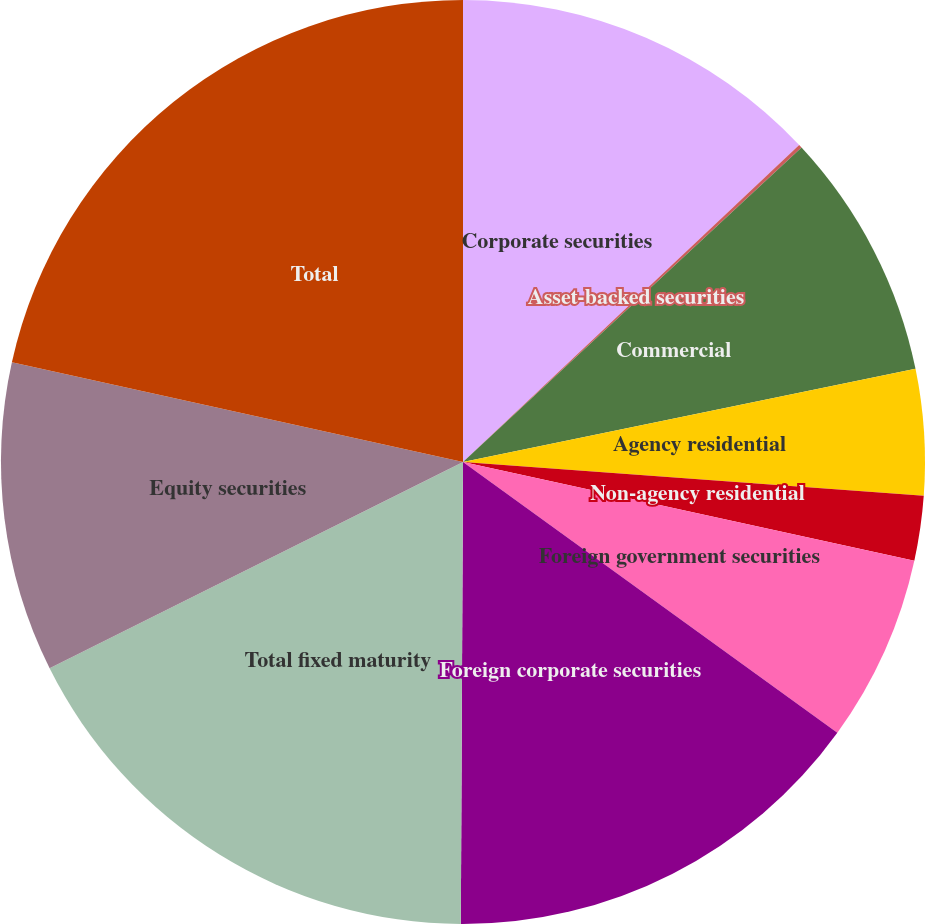Convert chart. <chart><loc_0><loc_0><loc_500><loc_500><pie_chart><fcel>Corporate securities<fcel>Asset-backed securities<fcel>Commercial<fcel>Agency residential<fcel>Non-agency residential<fcel>Foreign government securities<fcel>Foreign corporate securities<fcel>Total fixed maturity<fcel>Equity securities<fcel>Total<nl><fcel>12.97%<fcel>0.12%<fcel>8.68%<fcel>4.4%<fcel>2.26%<fcel>6.54%<fcel>15.11%<fcel>17.56%<fcel>10.83%<fcel>21.54%<nl></chart> 